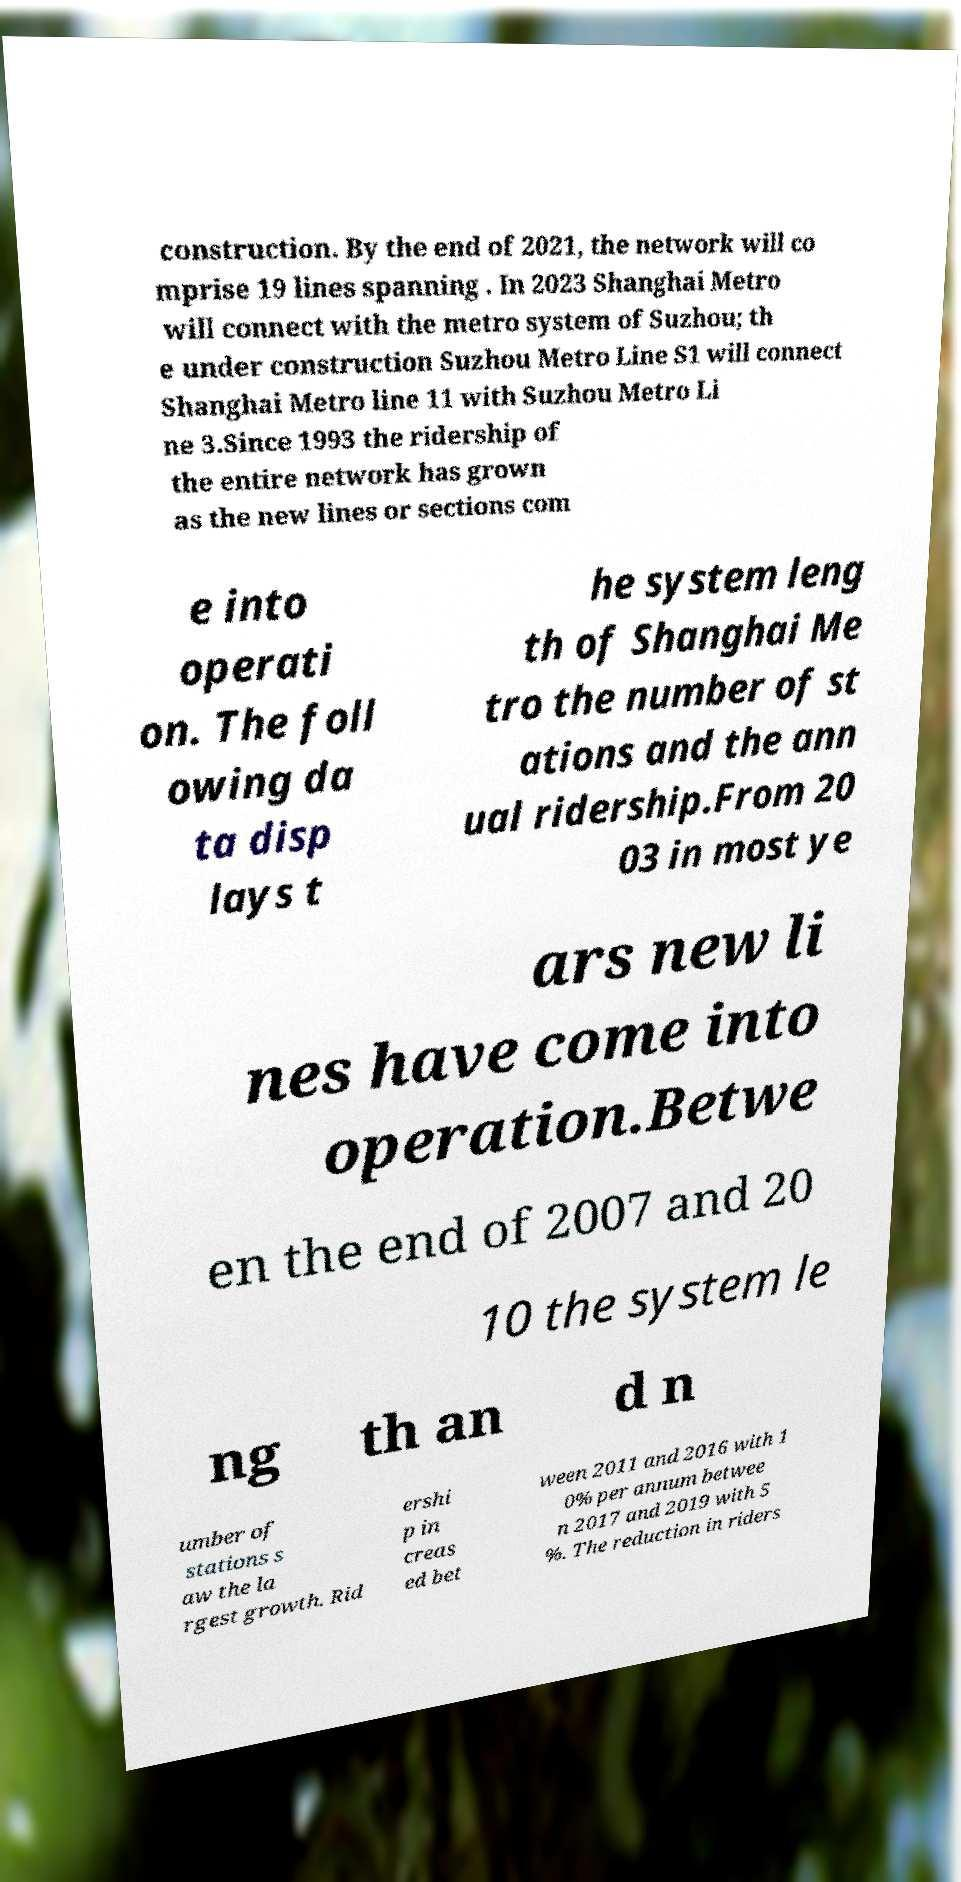For documentation purposes, I need the text within this image transcribed. Could you provide that? construction. By the end of 2021, the network will co mprise 19 lines spanning . In 2023 Shanghai Metro will connect with the metro system of Suzhou; th e under construction Suzhou Metro Line S1 will connect Shanghai Metro line 11 with Suzhou Metro Li ne 3.Since 1993 the ridership of the entire network has grown as the new lines or sections com e into operati on. The foll owing da ta disp lays t he system leng th of Shanghai Me tro the number of st ations and the ann ual ridership.From 20 03 in most ye ars new li nes have come into operation.Betwe en the end of 2007 and 20 10 the system le ng th an d n umber of stations s aw the la rgest growth. Rid ershi p in creas ed bet ween 2011 and 2016 with 1 0% per annum betwee n 2017 and 2019 with 5 %. The reduction in riders 